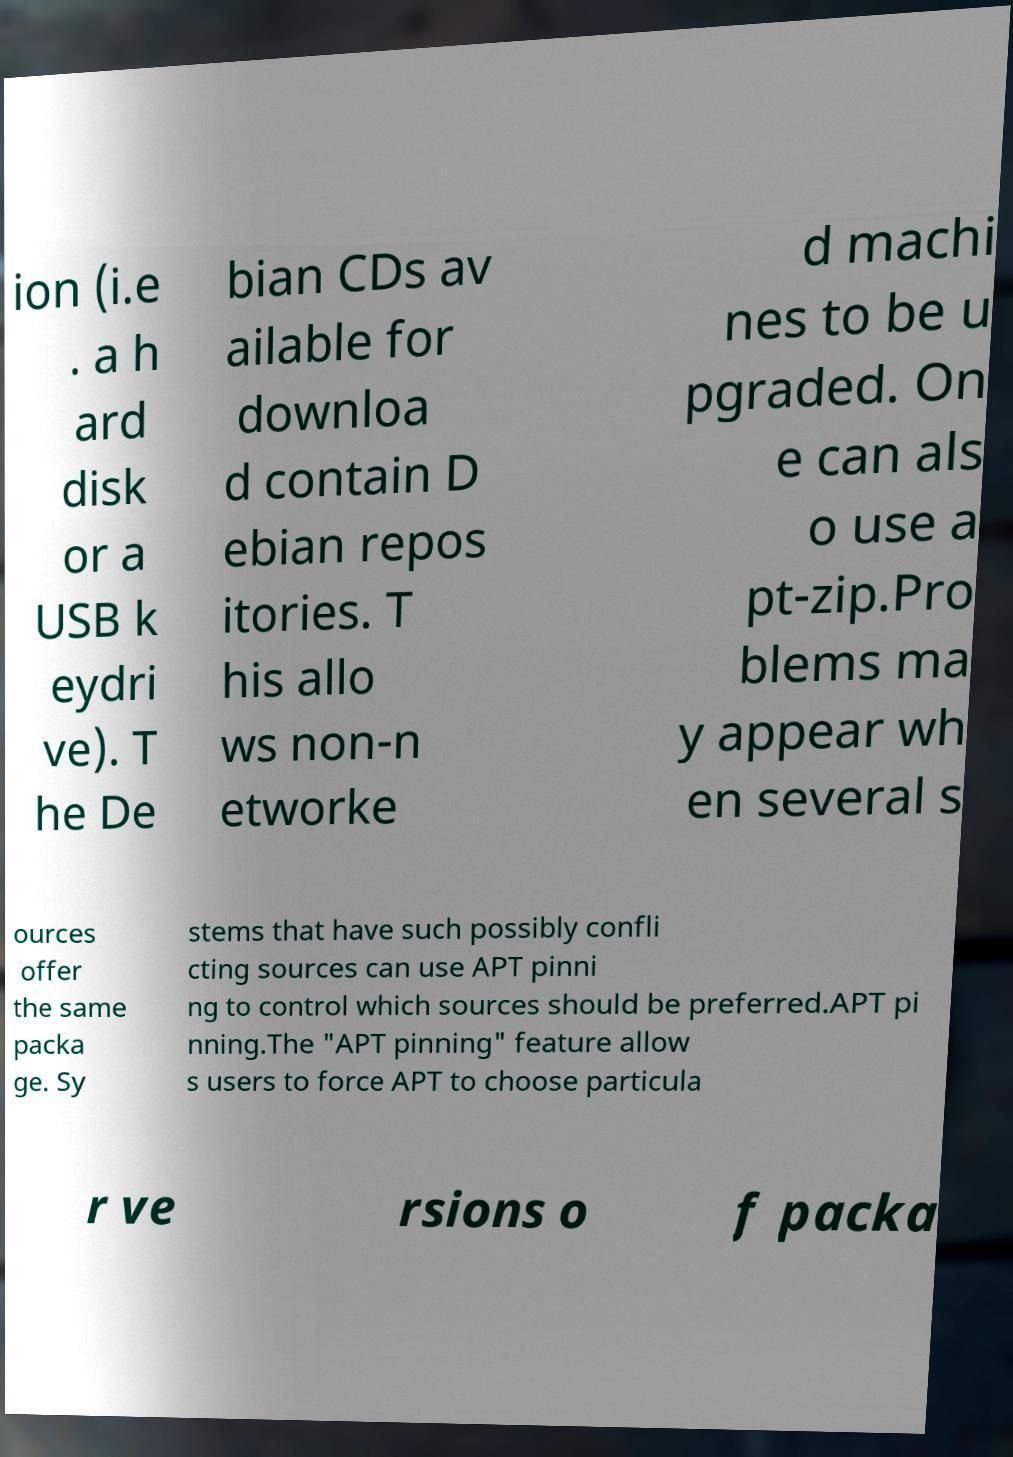Can you read and provide the text displayed in the image?This photo seems to have some interesting text. Can you extract and type it out for me? ion (i.e . a h ard disk or a USB k eydri ve). T he De bian CDs av ailable for downloa d contain D ebian repos itories. T his allo ws non-n etworke d machi nes to be u pgraded. On e can als o use a pt-zip.Pro blems ma y appear wh en several s ources offer the same packa ge. Sy stems that have such possibly confli cting sources can use APT pinni ng to control which sources should be preferred.APT pi nning.The "APT pinning" feature allow s users to force APT to choose particula r ve rsions o f packa 